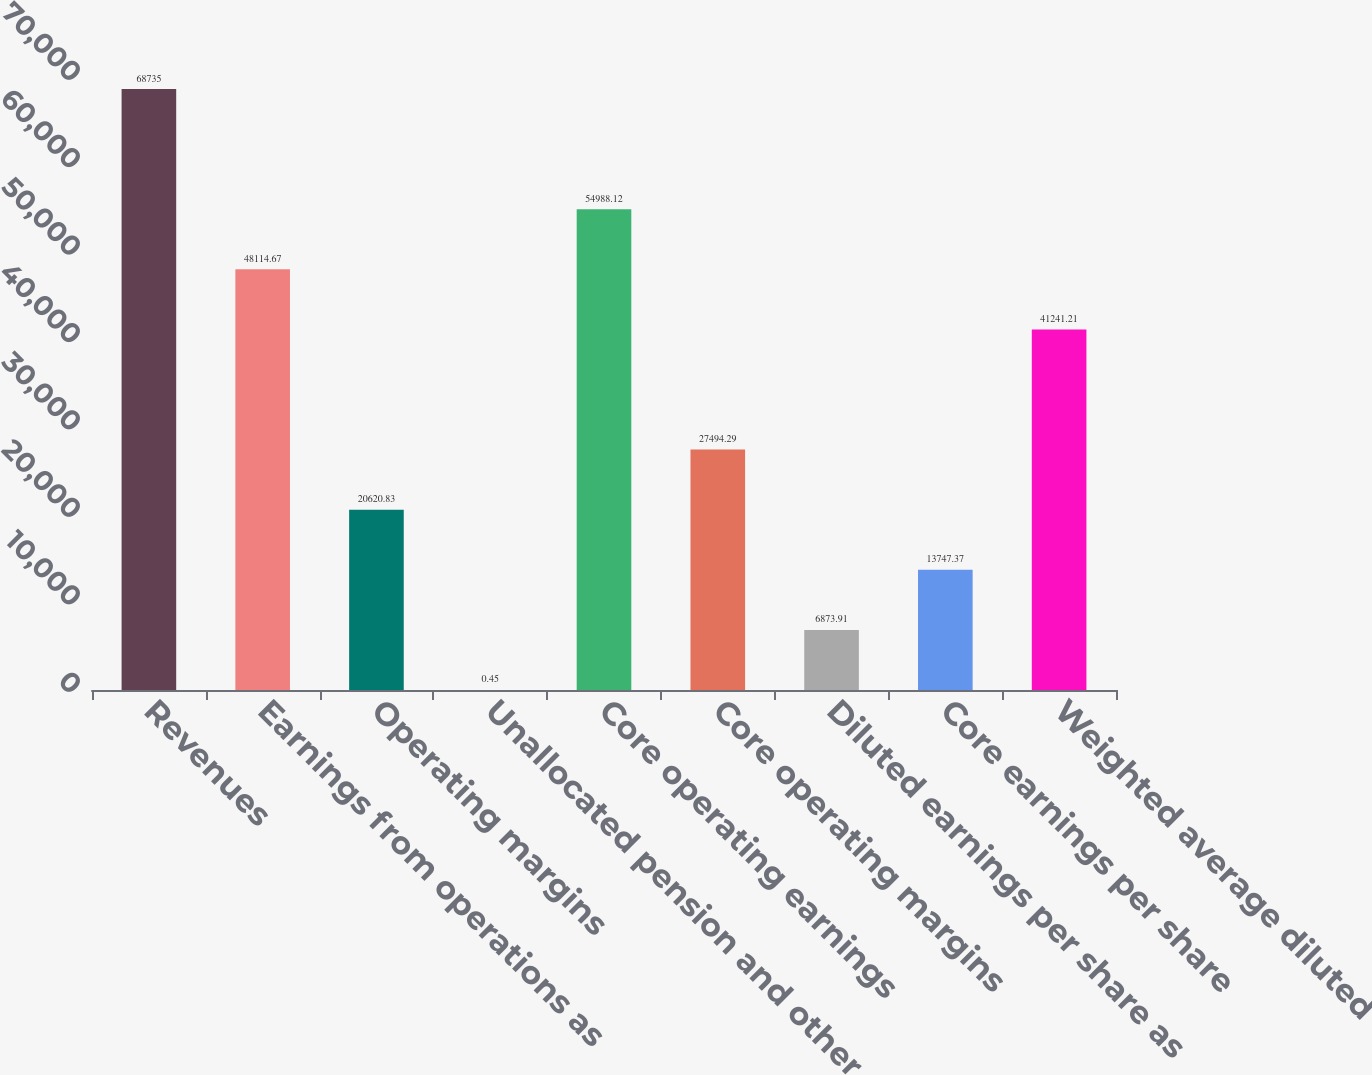<chart> <loc_0><loc_0><loc_500><loc_500><bar_chart><fcel>Revenues<fcel>Earnings from operations as<fcel>Operating margins<fcel>Unallocated pension and other<fcel>Core operating earnings<fcel>Core operating margins<fcel>Diluted earnings per share as<fcel>Core earnings per share<fcel>Weighted average diluted<nl><fcel>68735<fcel>48114.7<fcel>20620.8<fcel>0.45<fcel>54988.1<fcel>27494.3<fcel>6873.91<fcel>13747.4<fcel>41241.2<nl></chart> 